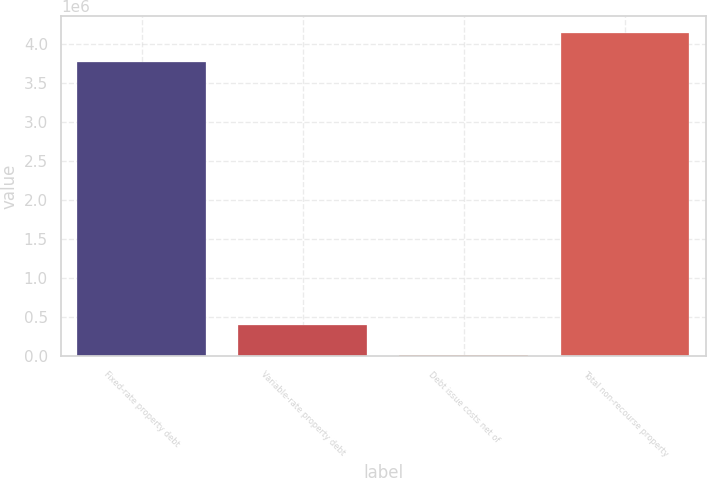Convert chart. <chart><loc_0><loc_0><loc_500><loc_500><bar_chart><fcel>Fixed-rate property debt<fcel>Variable-rate property debt<fcel>Debt issue costs net of<fcel>Total non-recourse property<nl><fcel>3.76124e+06<fcel>403831<fcel>24019<fcel>4.14105e+06<nl></chart> 